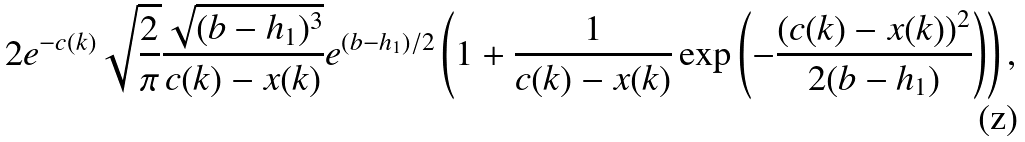<formula> <loc_0><loc_0><loc_500><loc_500>& 2 e ^ { - c ( k ) } \sqrt { \frac { 2 } { \pi } } \frac { \sqrt { ( b - h _ { 1 } ) ^ { 3 } } } { c ( k ) - x ( k ) } e ^ { ( b - h _ { 1 } ) / 2 } \left ( 1 + \frac { 1 } { c ( k ) - x ( k ) } \exp \left ( - \frac { ( c ( k ) - x ( k ) ) ^ { 2 } } { 2 ( b - h _ { 1 } ) } \right ) \right ) ,</formula> 